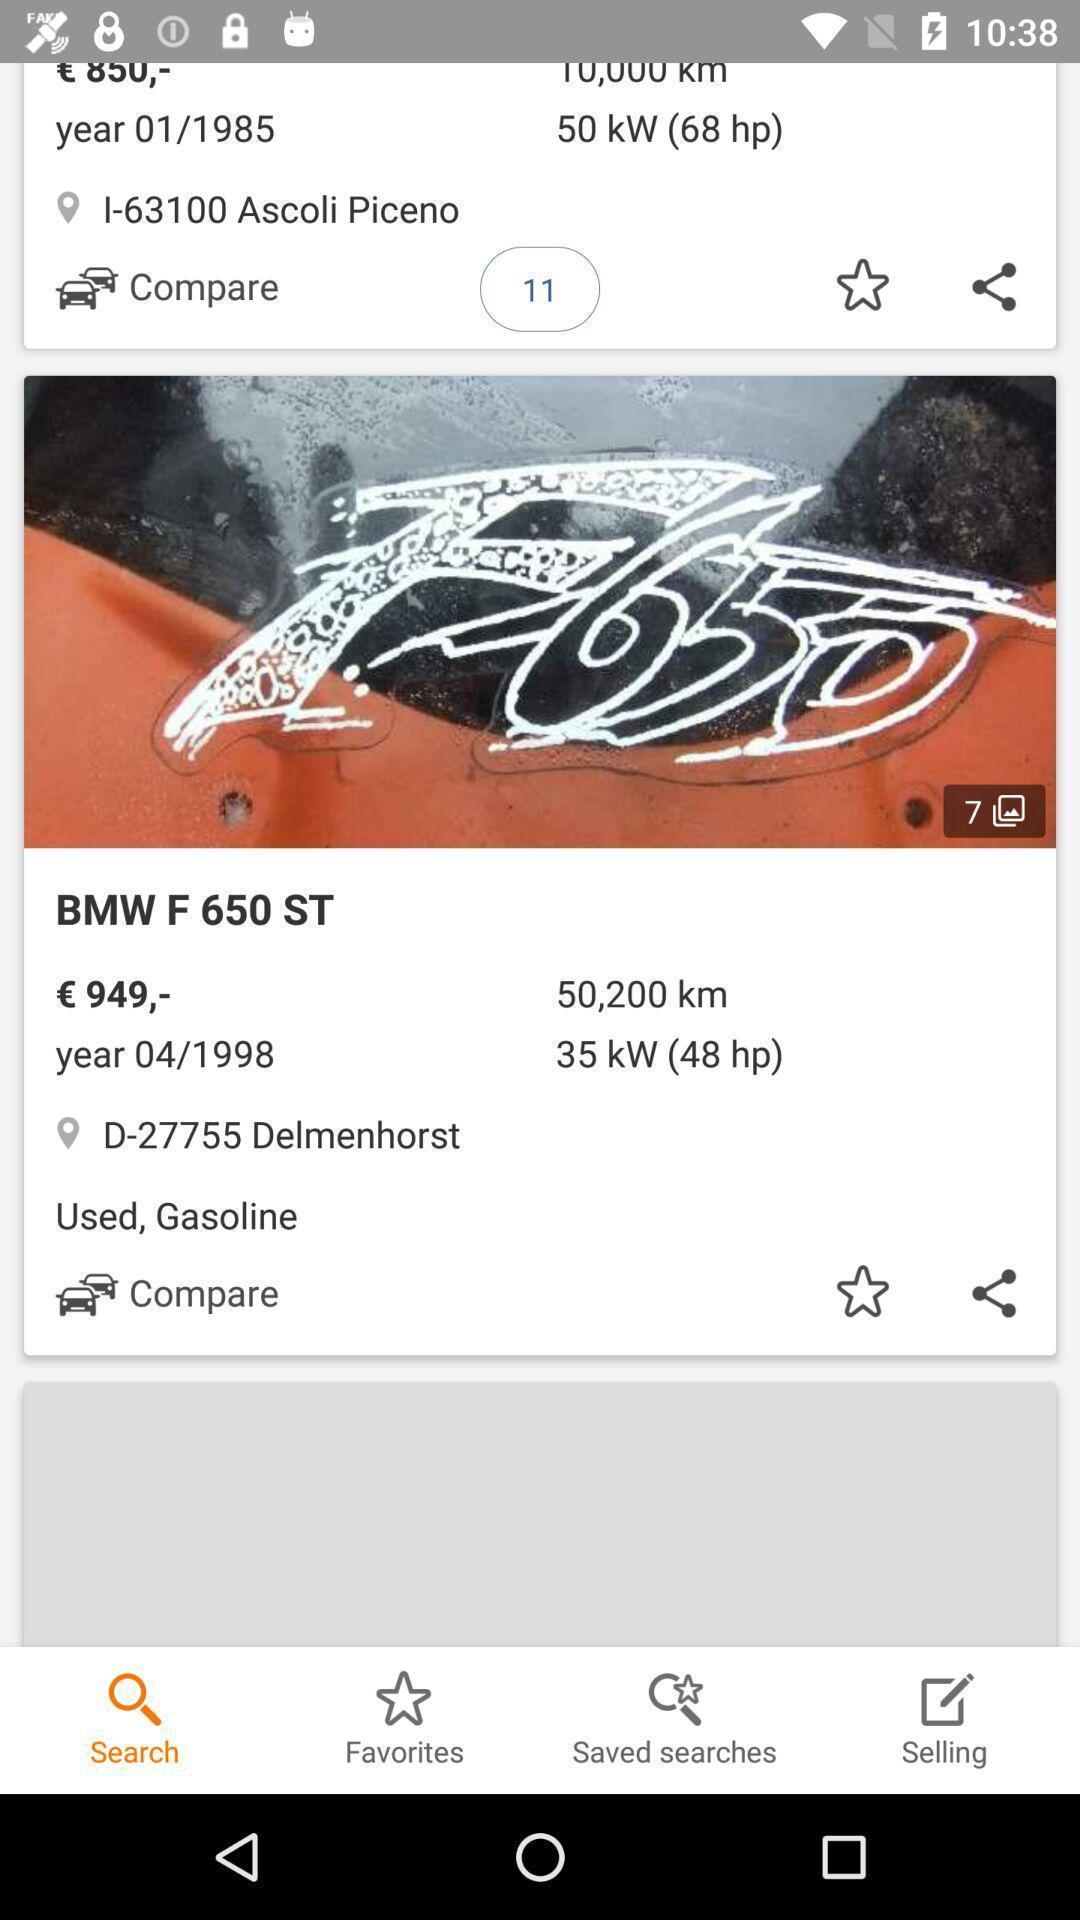What details can you identify in this image? Page showing comparison of cars. 